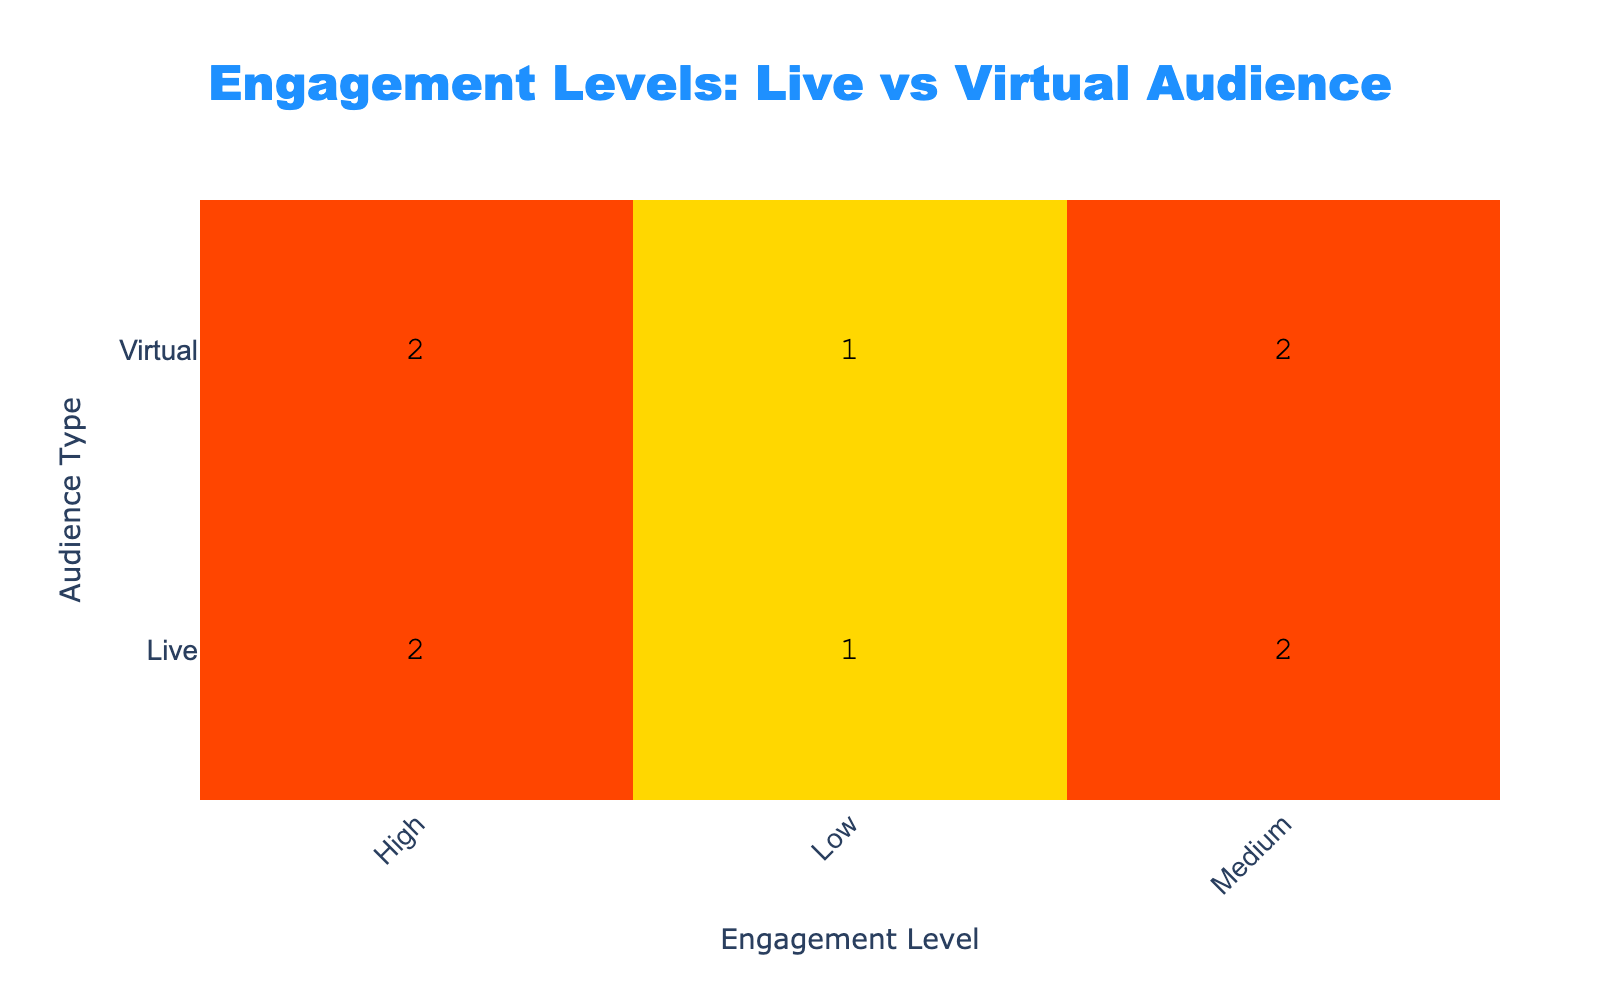What is the total number of live audience members with a high engagement level? From the table, we can see there are two entries for the live audience with a high engagement level. The counts for live, high engagement are 2. Therefore, the total number is 2
Answer: 2 Which audience type has the most medium engagement ratings? The medium engagement ratings for both the live and virtual audiences show that the live audience has two counts of medium ratings, while the virtual audience has one count. Thus, the audience type with the most medium ratings is live
Answer: Live What is the average niche joke rating for the virtual audience? To find the average, we will sum the niche joke ratings for the virtual audience entries (8 + 7 + 4 + 6 + 5) = 30. There are 5 entries, so the average is 30/5 = 6
Answer: 6 Is it true that the live audience has a higher average engagement level than the virtual audience? To determine this, we first find the counts for each engagement level. The live audience has (high: 2, medium: 2, low: 1) giving 2*3 + 2*2 + 1*1 = 12 engagement units. The virtual audience has (high: 3, medium: 2, low: 1) giving 3*3 + 2*2 + 1*1 = 14 engagement units. Comparing the two averages, 12/5 = 2.4 for live and 14/5 = 2.8 for virtual, thus it is false that the live audience has a higher average engagement level
Answer: False How many entries in the table show low engagement for the virtual audience? From the table, it is clear there is only one entry where the virtual audience has a low engagement level, which is explicitly stated. Therefore, the answer is 1
Answer: 1 